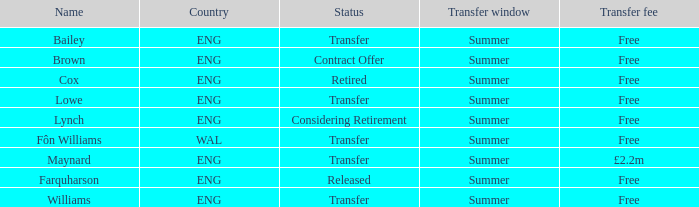What is the transfer window with a status of transfer from the country of Wal? Summer. 